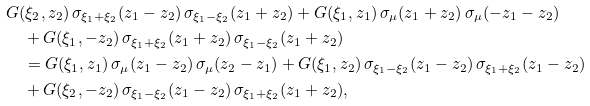<formula> <loc_0><loc_0><loc_500><loc_500>& G ( \xi _ { 2 } , z _ { 2 } ) \, \sigma _ { \xi _ { 1 } + \xi _ { 2 } } ( z _ { 1 } - z _ { 2 } ) \, \sigma _ { \xi _ { 1 } - \xi _ { 2 } } ( z _ { 1 } + z _ { 2 } ) + G ( \xi _ { 1 } , z _ { 1 } ) \, \sigma _ { \mu } ( z _ { 1 } + z _ { 2 } ) \, \sigma _ { \mu } ( - z _ { 1 } - z _ { 2 } ) \\ & \quad + G ( \xi _ { 1 } , - z _ { 2 } ) \, \sigma _ { \xi _ { 1 } + \xi _ { 2 } } ( z _ { 1 } + z _ { 2 } ) \, \sigma _ { \xi _ { 1 } - \xi _ { 2 } } ( z _ { 1 } + z _ { 2 } ) \\ & \quad = G ( \xi _ { 1 } , z _ { 1 } ) \, \sigma _ { \mu } ( z _ { 1 } - z _ { 2 } ) \, \sigma _ { \mu } ( z _ { 2 } - z _ { 1 } ) + G ( \xi _ { 1 } , z _ { 2 } ) \, \sigma _ { \xi _ { 1 } - \xi _ { 2 } } ( z _ { 1 } - z _ { 2 } ) \, \sigma _ { \xi _ { 1 } + \xi _ { 2 } } ( z _ { 1 } - z _ { 2 } ) \\ & \quad + G ( \xi _ { 2 } , - z _ { 2 } ) \, \sigma _ { \xi _ { 1 } - \xi _ { 2 } } ( z _ { 1 } - z _ { 2 } ) \, \sigma _ { \xi _ { 1 } + \xi _ { 2 } } ( z _ { 1 } + z _ { 2 } ) ,</formula> 